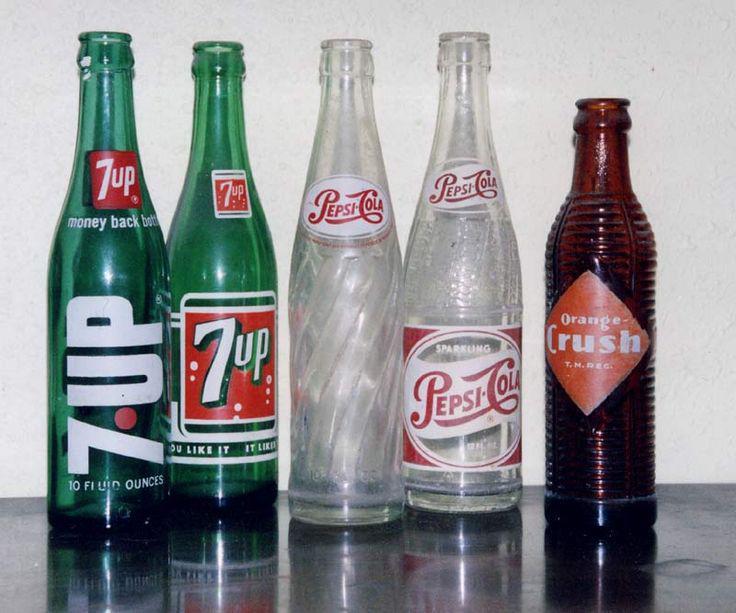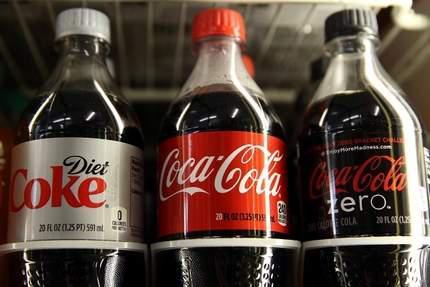The first image is the image on the left, the second image is the image on the right. For the images shown, is this caption "The left image shows a row of at least three different glass soda bottles, and the right image includes multiple filled plastic soda bottles with different labels." true? Answer yes or no. Yes. The first image is the image on the left, the second image is the image on the right. For the images shown, is this caption "Rows of red-capped cola bottles with red and white labels are in one image, all but one with a second white rectangular label on the neck." true? Answer yes or no. No. 